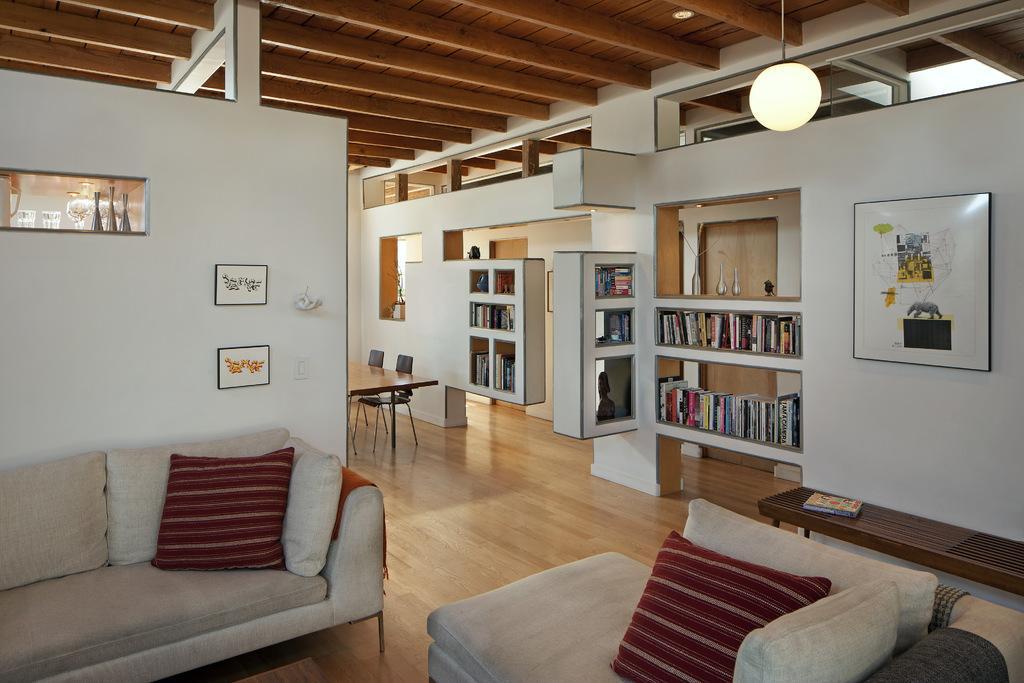Please provide a concise description of this image. In this image i can see a couch,pillows,books which are in the shelves,paintings attached to the wall,light and a dining table. 